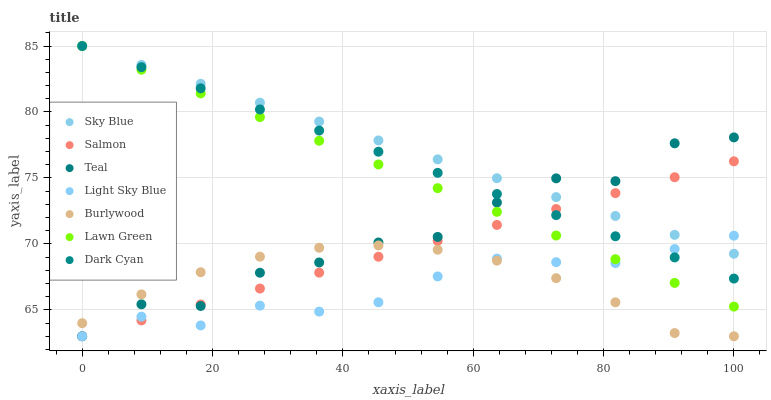Does Light Sky Blue have the minimum area under the curve?
Answer yes or no. Yes. Does Sky Blue have the maximum area under the curve?
Answer yes or no. Yes. Does Burlywood have the minimum area under the curve?
Answer yes or no. No. Does Burlywood have the maximum area under the curve?
Answer yes or no. No. Is Lawn Green the smoothest?
Answer yes or no. Yes. Is Teal the roughest?
Answer yes or no. Yes. Is Burlywood the smoothest?
Answer yes or no. No. Is Burlywood the roughest?
Answer yes or no. No. Does Burlywood have the lowest value?
Answer yes or no. Yes. Does Dark Cyan have the lowest value?
Answer yes or no. No. Does Sky Blue have the highest value?
Answer yes or no. Yes. Does Salmon have the highest value?
Answer yes or no. No. Is Burlywood less than Dark Cyan?
Answer yes or no. Yes. Is Lawn Green greater than Burlywood?
Answer yes or no. Yes. Does Lawn Green intersect Light Sky Blue?
Answer yes or no. Yes. Is Lawn Green less than Light Sky Blue?
Answer yes or no. No. Is Lawn Green greater than Light Sky Blue?
Answer yes or no. No. Does Burlywood intersect Dark Cyan?
Answer yes or no. No. 